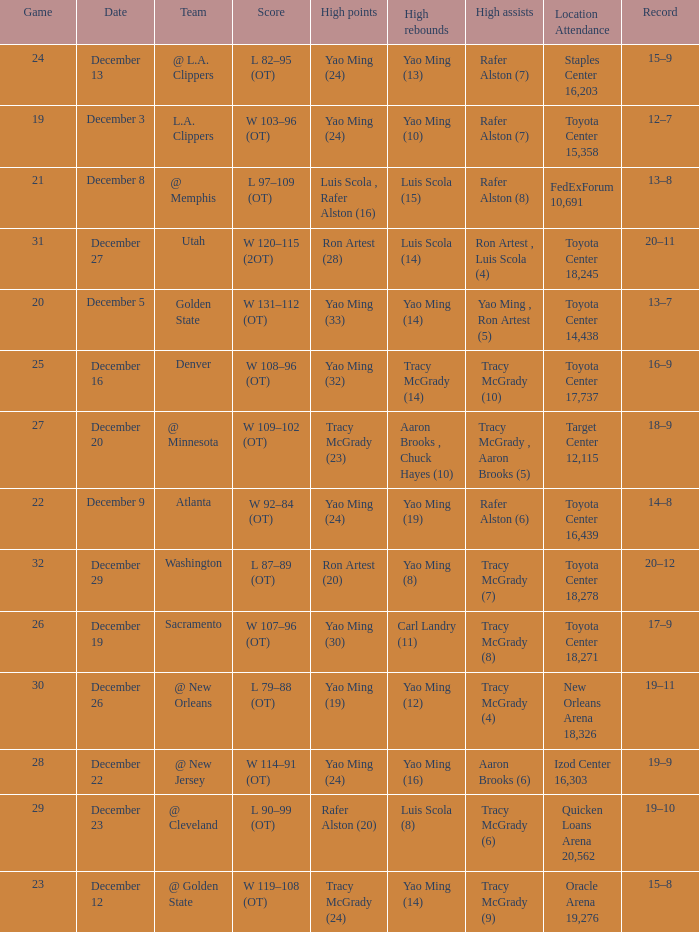When aaron brooks (6) had the highest amount of assists what is the date? December 22. 